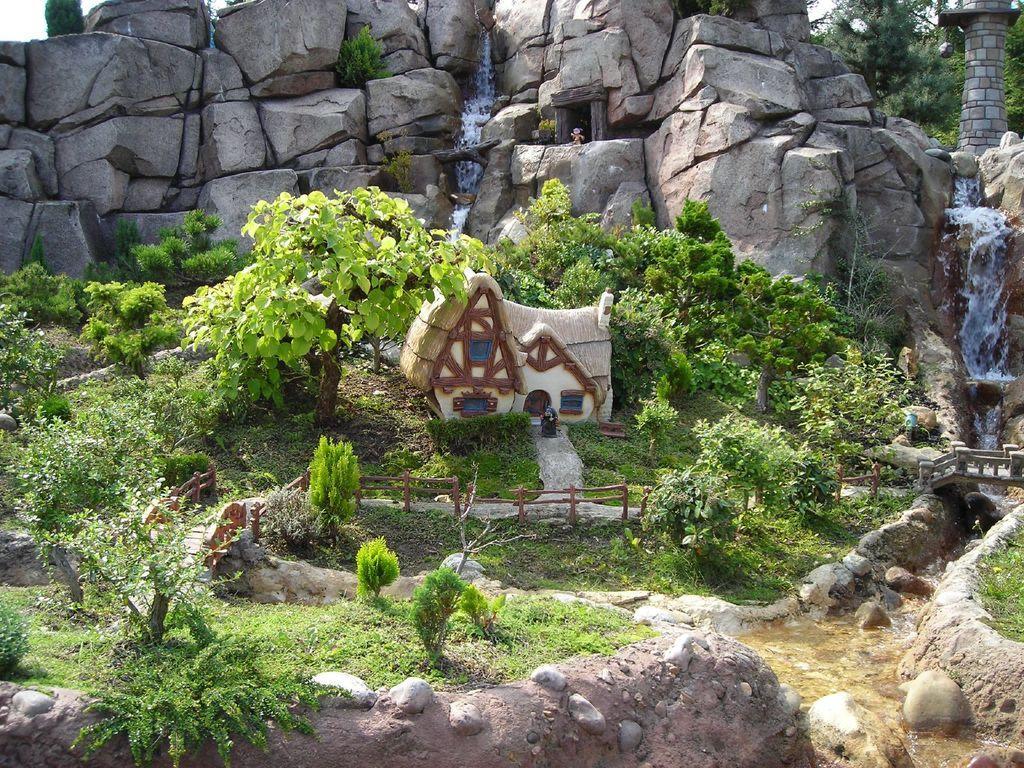In one or two sentences, can you explain what this image depicts? This image consists of a cartoon world. It looks like it is clicked outside. In the front, there is a small house. In the background, there are rocks. On the right, there is a waterfall. In the front, we can see many plants and trees. 